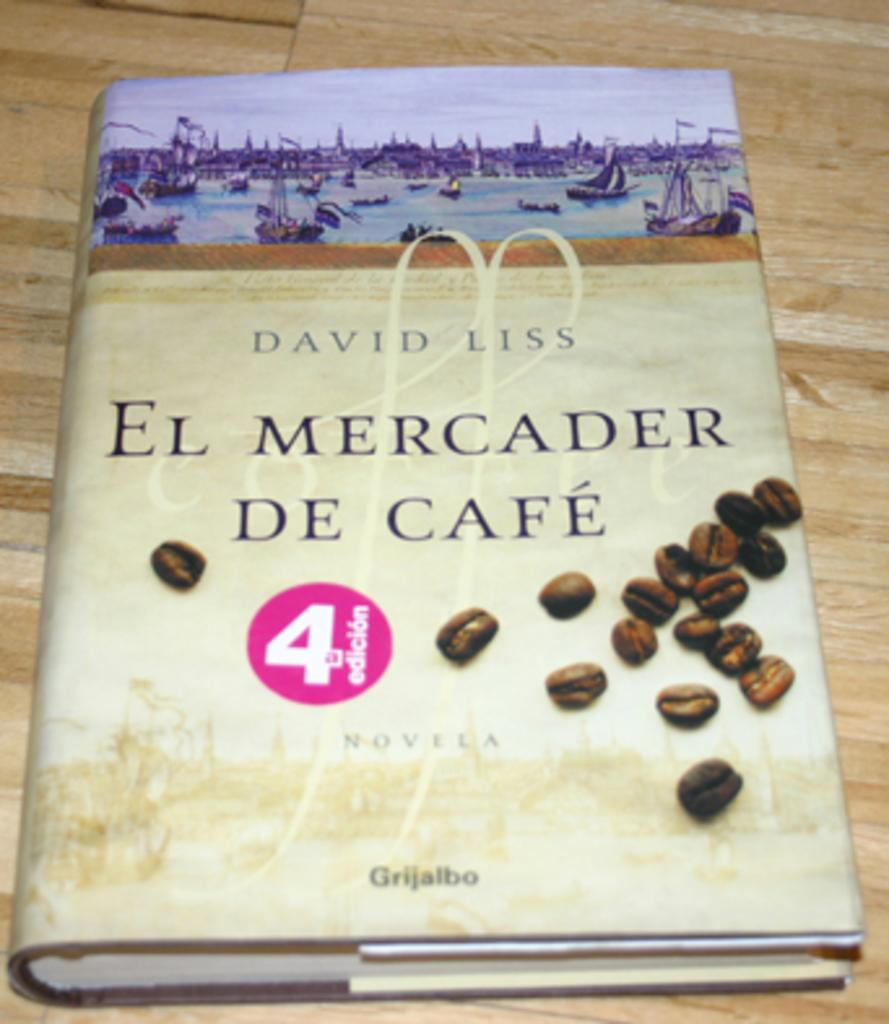<image>
Present a compact description of the photo's key features. A book cover has the title El Mercader De Cafe. 